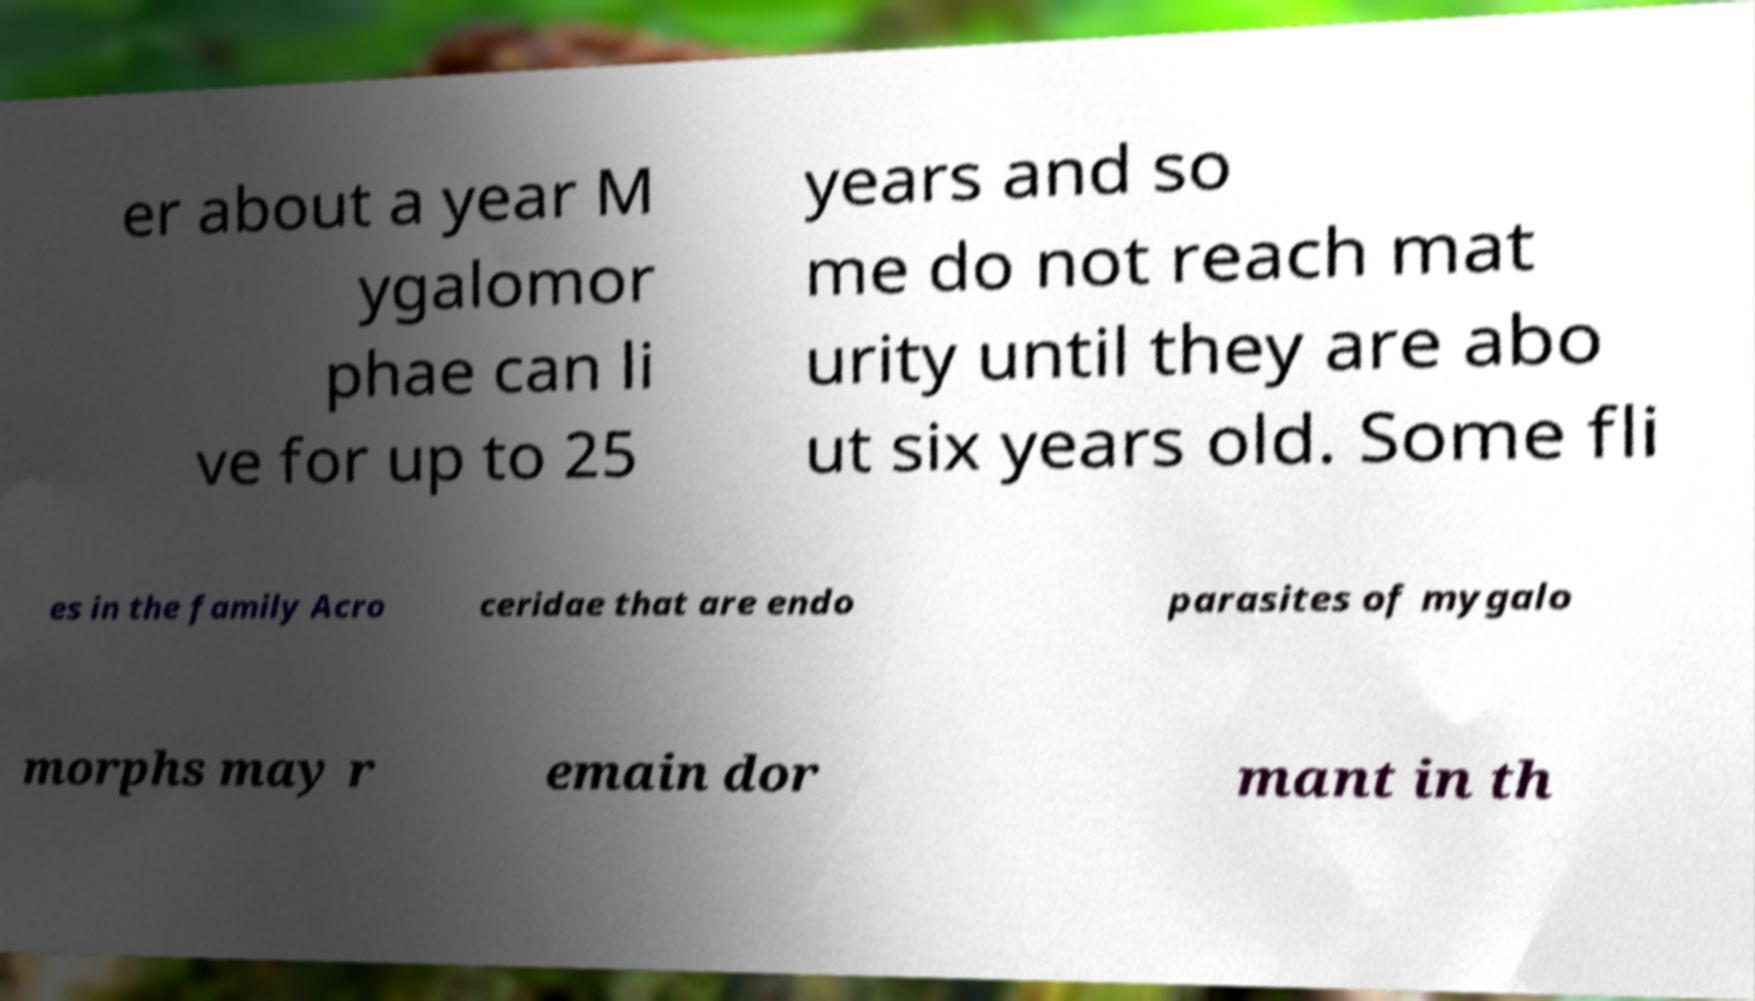Could you assist in decoding the text presented in this image and type it out clearly? er about a year M ygalomor phae can li ve for up to 25 years and so me do not reach mat urity until they are abo ut six years old. Some fli es in the family Acro ceridae that are endo parasites of mygalo morphs may r emain dor mant in th 